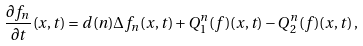Convert formula to latex. <formula><loc_0><loc_0><loc_500><loc_500>\frac { \partial { f _ { n } } } { \partial t } ( x , t ) = d ( n ) \Delta f _ { n } ( x , t ) + Q ^ { n } _ { 1 } ( f ) ( x , t ) - Q ^ { n } _ { 2 } ( f ) ( x , t ) \, ,</formula> 